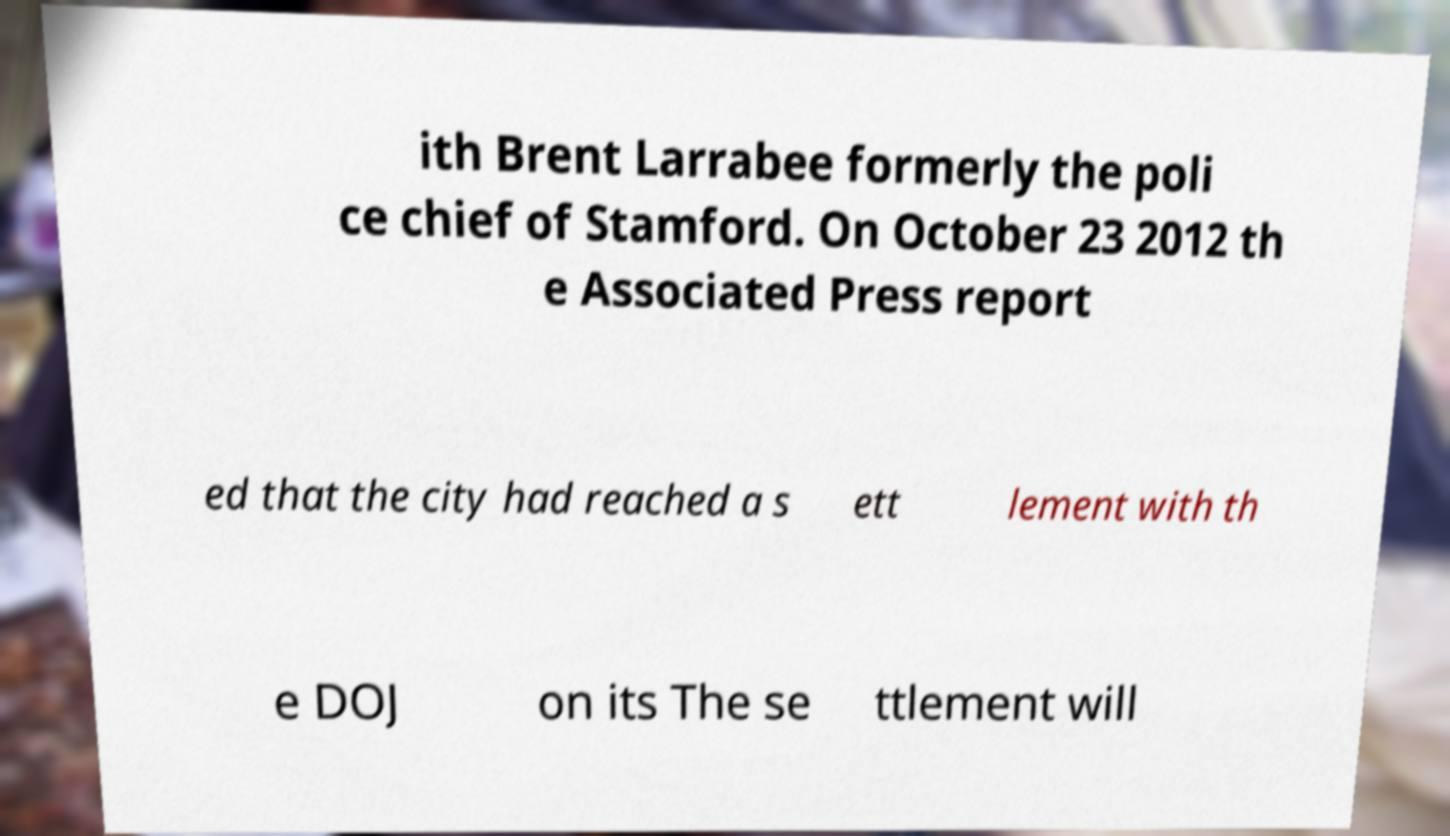I need the written content from this picture converted into text. Can you do that? ith Brent Larrabee formerly the poli ce chief of Stamford. On October 23 2012 th e Associated Press report ed that the city had reached a s ett lement with th e DOJ on its The se ttlement will 